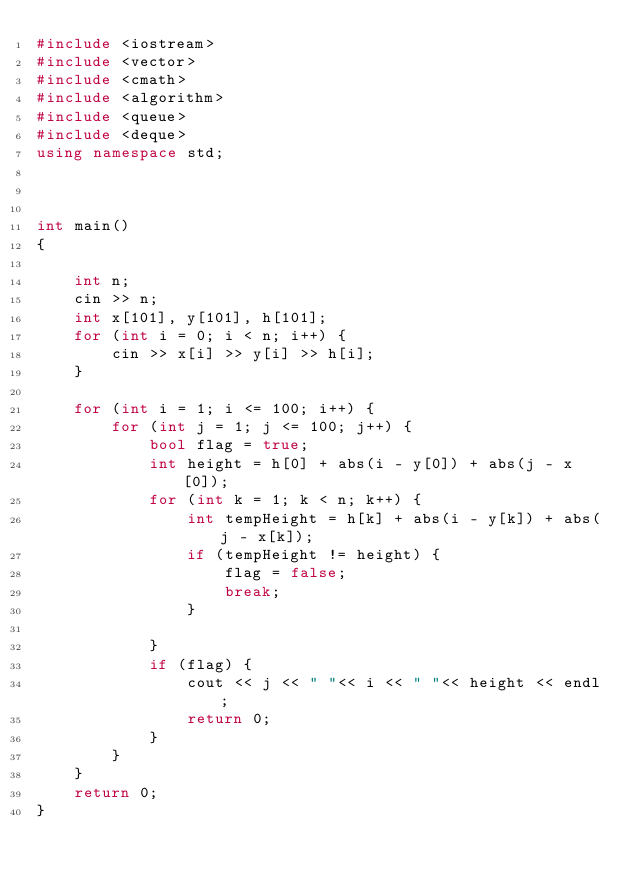<code> <loc_0><loc_0><loc_500><loc_500><_C++_>#include <iostream>
#include <vector>
#include <cmath>
#include <algorithm>
#include <queue>
#include <deque>
using namespace std;



int main()
{
	
	int n;
	cin >> n;
	int x[101], y[101], h[101];
	for (int i = 0; i < n; i++) {
		cin >> x[i] >> y[i] >> h[i];
	}

	for (int i = 1; i <= 100; i++) {
		for (int j = 1; j <= 100; j++) {
			bool flag = true;
			int height = h[0] + abs(i - y[0]) + abs(j - x[0]);
			for (int k = 1; k < n; k++) {
				int tempHeight = h[k] + abs(i - y[k]) + abs(j - x[k]);
				if (tempHeight != height) {
					flag = false;
					break;
				}
				
			}
			if (flag) {
				cout << j << " "<< i << " "<< height << endl;
				return 0;
			}
		}
	}
	return 0;
}
</code> 